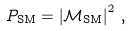Convert formula to latex. <formula><loc_0><loc_0><loc_500><loc_500>P _ { \text {SM} } = \left | \mathcal { M } _ { \text {SM} } \right | ^ { 2 } \, ,</formula> 